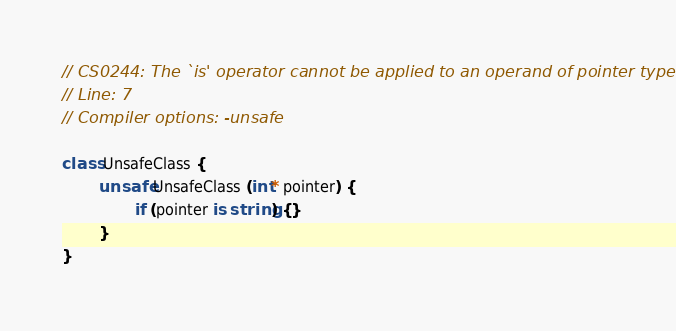Convert code to text. <code><loc_0><loc_0><loc_500><loc_500><_C#_>// CS0244: The `is' operator cannot be applied to an operand of pointer type
// Line: 7
// Compiler options: -unsafe

class UnsafeClass {
        unsafe UnsafeClass (int* pointer) {
                if (pointer is string) {}
        }
}


</code> 